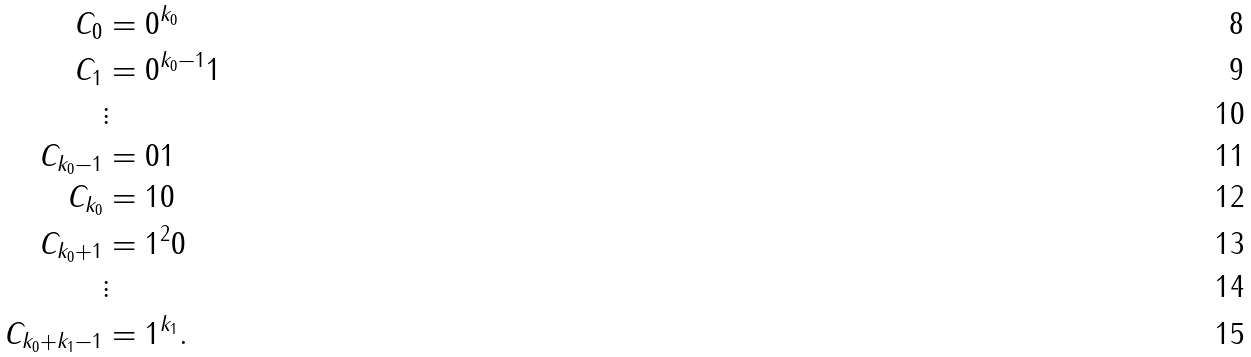Convert formula to latex. <formula><loc_0><loc_0><loc_500><loc_500>C _ { 0 } & = 0 ^ { k _ { 0 } } \\ C _ { 1 } & = 0 ^ { k _ { 0 } - 1 } 1 \\ & \vdots \\ C _ { k _ { 0 } - 1 } & = 0 1 \\ C _ { k _ { 0 } } & = 1 0 \\ C _ { k _ { 0 } + 1 } & = 1 ^ { 2 } 0 \\ & \vdots \\ C _ { k _ { 0 } + k _ { 1 } - 1 } & = 1 ^ { k _ { 1 } } .</formula> 